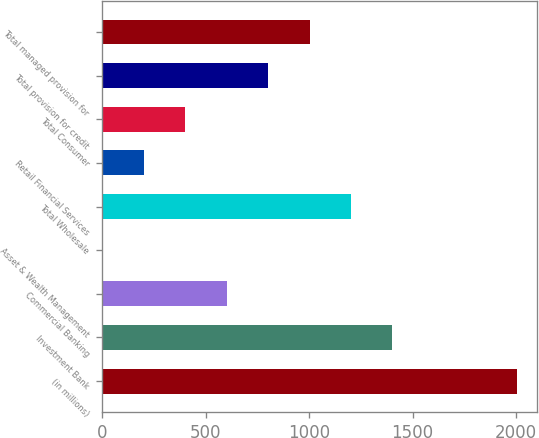<chart> <loc_0><loc_0><loc_500><loc_500><bar_chart><fcel>(in millions)<fcel>Investment Bank<fcel>Commercial Banking<fcel>Asset & Wealth Management<fcel>Total Wholesale<fcel>Retail Financial Services<fcel>Total Consumer<fcel>Total provision for credit<fcel>Total managed provision for<nl><fcel>2003<fcel>1402.4<fcel>601.6<fcel>1<fcel>1202.2<fcel>201.2<fcel>401.4<fcel>801.8<fcel>1002<nl></chart> 